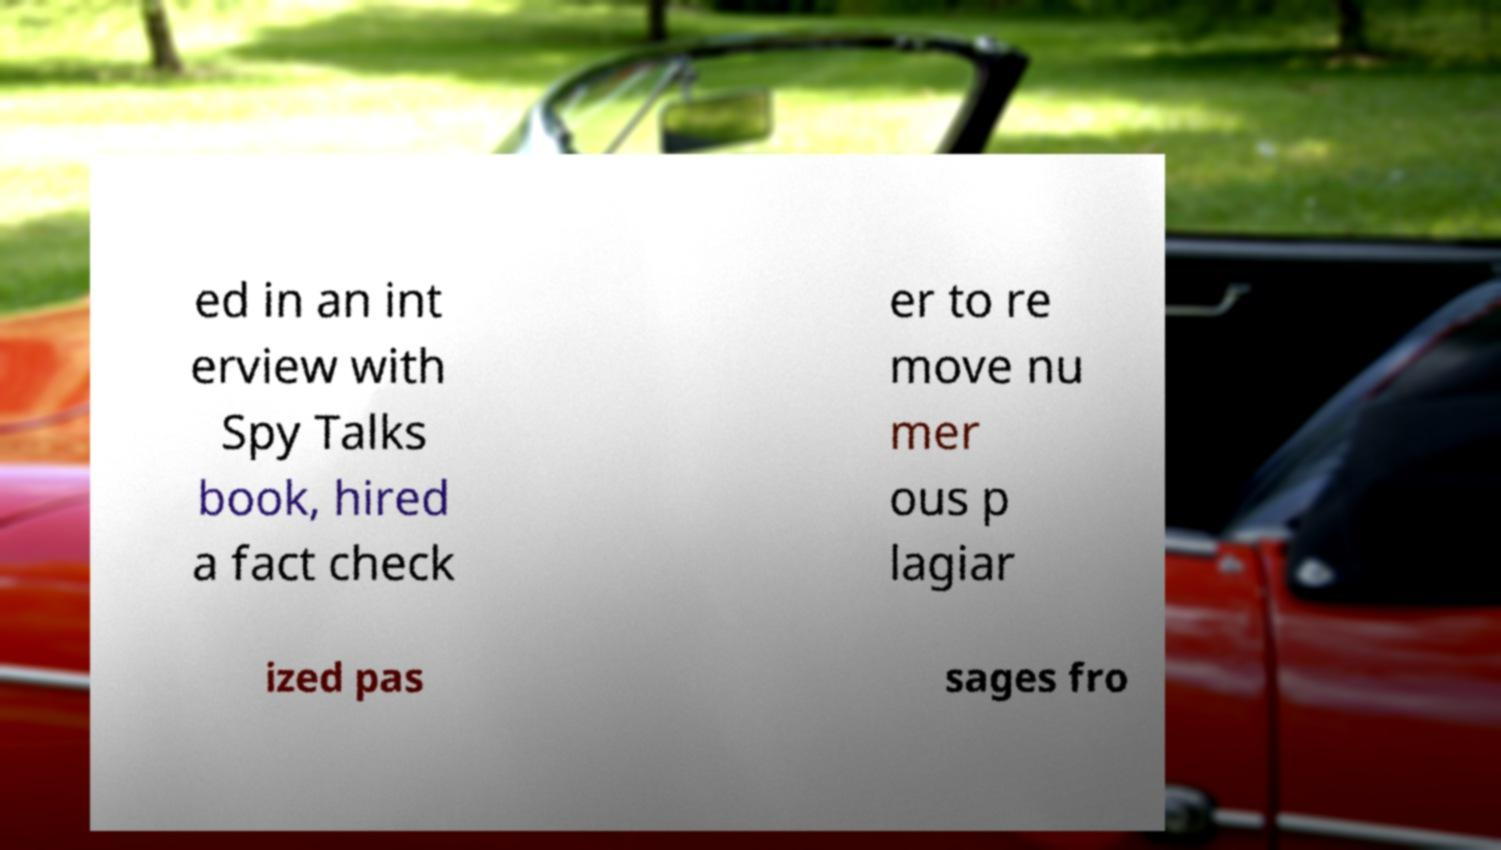Please read and relay the text visible in this image. What does it say? ed in an int erview with Spy Talks book, hired a fact check er to re move nu mer ous p lagiar ized pas sages fro 